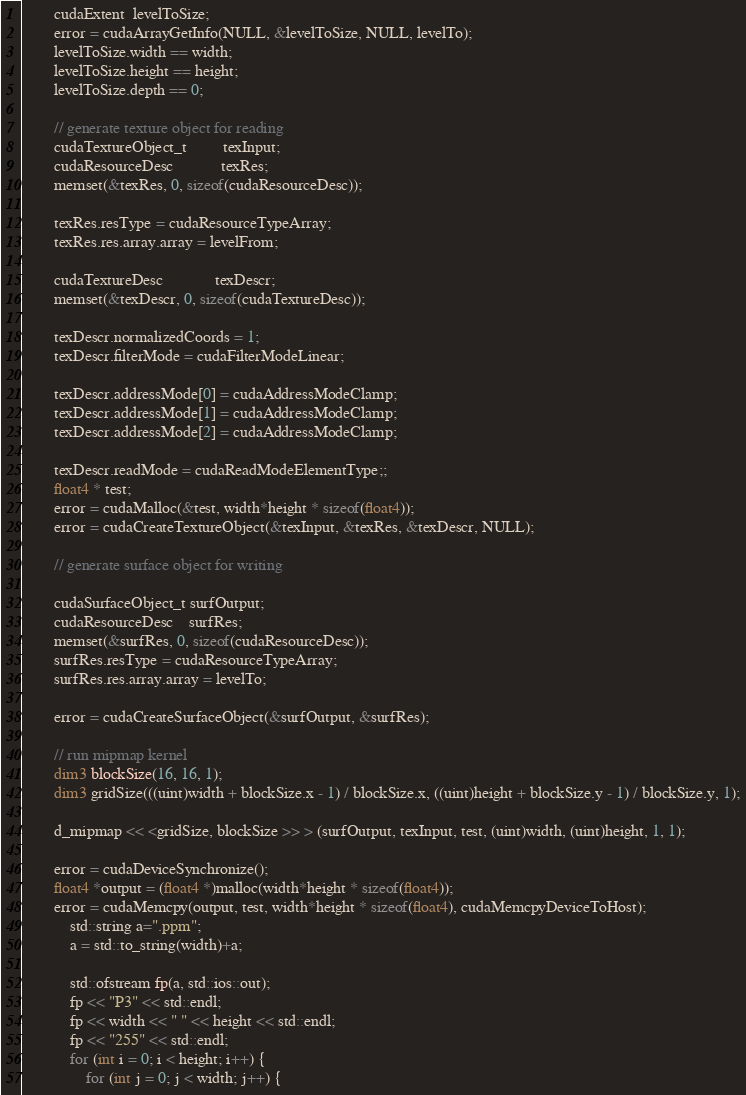<code> <loc_0><loc_0><loc_500><loc_500><_Cuda_>
		cudaExtent  levelToSize;
		error = cudaArrayGetInfo(NULL, &levelToSize, NULL, levelTo);
		levelToSize.width == width;
		levelToSize.height == height;
		levelToSize.depth == 0;

		// generate texture object for reading
		cudaTextureObject_t         texInput;
		cudaResourceDesc            texRes;
		memset(&texRes, 0, sizeof(cudaResourceDesc));

		texRes.resType = cudaResourceTypeArray;
		texRes.res.array.array = levelFrom;

		cudaTextureDesc             texDescr;
		memset(&texDescr, 0, sizeof(cudaTextureDesc));

		texDescr.normalizedCoords = 1;
		texDescr.filterMode = cudaFilterModeLinear;

		texDescr.addressMode[0] = cudaAddressModeClamp;
		texDescr.addressMode[1] = cudaAddressModeClamp;
		texDescr.addressMode[2] = cudaAddressModeClamp;

		texDescr.readMode = cudaReadModeElementType;;
		float4 * test;
		error = cudaMalloc(&test, width*height * sizeof(float4));
		error = cudaCreateTextureObject(&texInput, &texRes, &texDescr, NULL);

		// generate surface object for writing

		cudaSurfaceObject_t surfOutput;
		cudaResourceDesc    surfRes;
		memset(&surfRes, 0, sizeof(cudaResourceDesc));
		surfRes.resType = cudaResourceTypeArray;
		surfRes.res.array.array = levelTo;

		error = cudaCreateSurfaceObject(&surfOutput, &surfRes);

		// run mipmap kernel
		dim3 blockSize(16, 16, 1);
		dim3 gridSize(((uint)width + blockSize.x - 1) / blockSize.x, ((uint)height + blockSize.y - 1) / blockSize.y, 1);

		d_mipmap << <gridSize, blockSize >> > (surfOutput, texInput, test, (uint)width, (uint)height, 1, 1);

		error = cudaDeviceSynchronize();
		float4 *output = (float4 *)malloc(width*height * sizeof(float4));
		error = cudaMemcpy(output, test, width*height * sizeof(float4), cudaMemcpyDeviceToHost);
			std::string a=".ppm";
			a = std::to_string(width)+a;

			std::ofstream fp(a, std::ios::out);
			fp << "P3" << std::endl;
			fp << width << " " << height << std::endl;
			fp << "255" << std::endl;
			for (int i = 0; i < height; i++) {
				for (int j = 0; j < width; j++) {</code> 